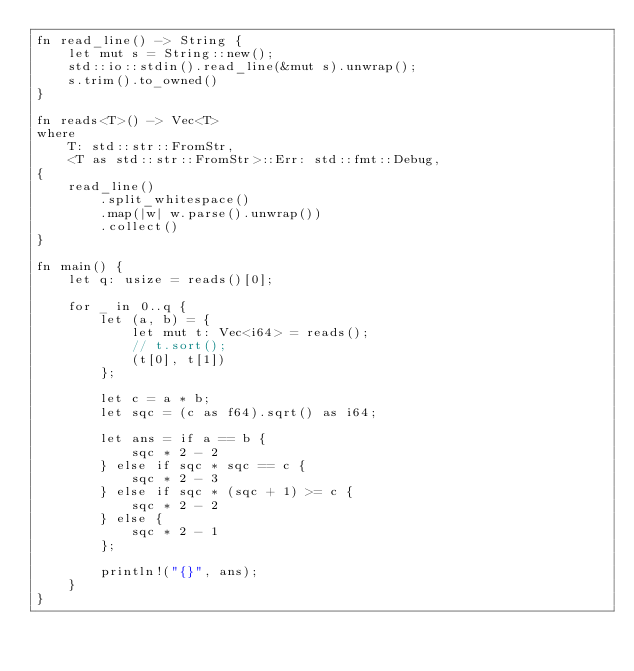<code> <loc_0><loc_0><loc_500><loc_500><_Rust_>fn read_line() -> String {
    let mut s = String::new();
    std::io::stdin().read_line(&mut s).unwrap();
    s.trim().to_owned()
}

fn reads<T>() -> Vec<T>
where
    T: std::str::FromStr,
    <T as std::str::FromStr>::Err: std::fmt::Debug,
{
    read_line()
        .split_whitespace()
        .map(|w| w.parse().unwrap())
        .collect()
}

fn main() {
    let q: usize = reads()[0];

    for _ in 0..q {
        let (a, b) = {
            let mut t: Vec<i64> = reads();
            // t.sort();
            (t[0], t[1])
        };

        let c = a * b;
        let sqc = (c as f64).sqrt() as i64;

        let ans = if a == b {
            sqc * 2 - 2
        } else if sqc * sqc == c {
            sqc * 2 - 3
        } else if sqc * (sqc + 1) >= c {
            sqc * 2 - 2
        } else {
            sqc * 2 - 1
        };

        println!("{}", ans);
    }
}
</code> 